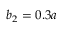Convert formula to latex. <formula><loc_0><loc_0><loc_500><loc_500>b _ { 2 } = 0 . 3 a</formula> 